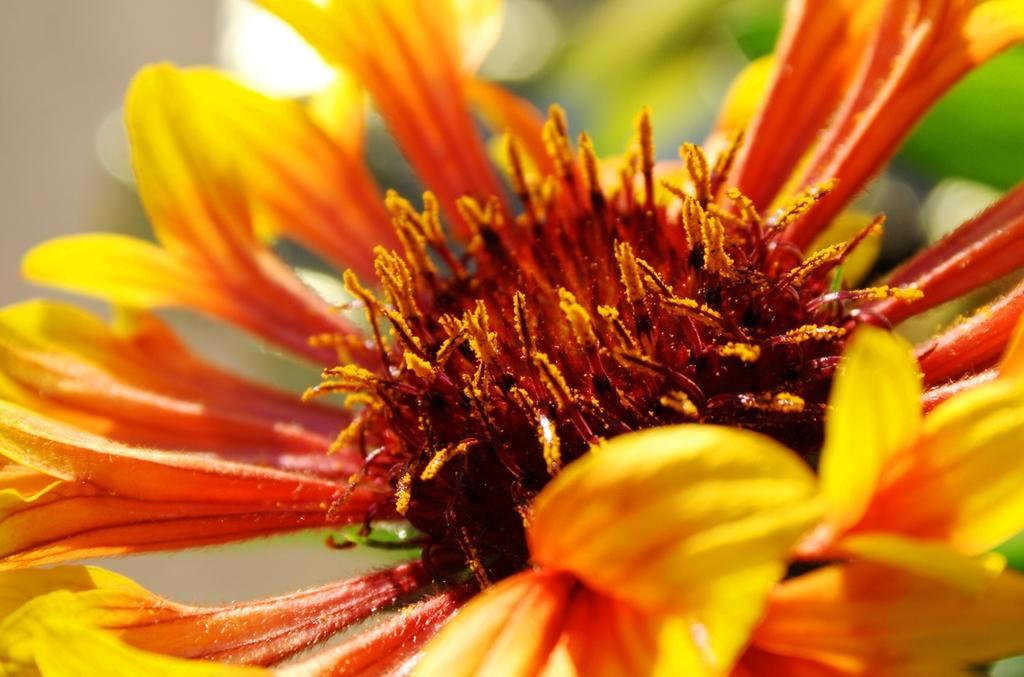Can you describe this image briefly? In this image I can see flower which is in orange and yellow color. 